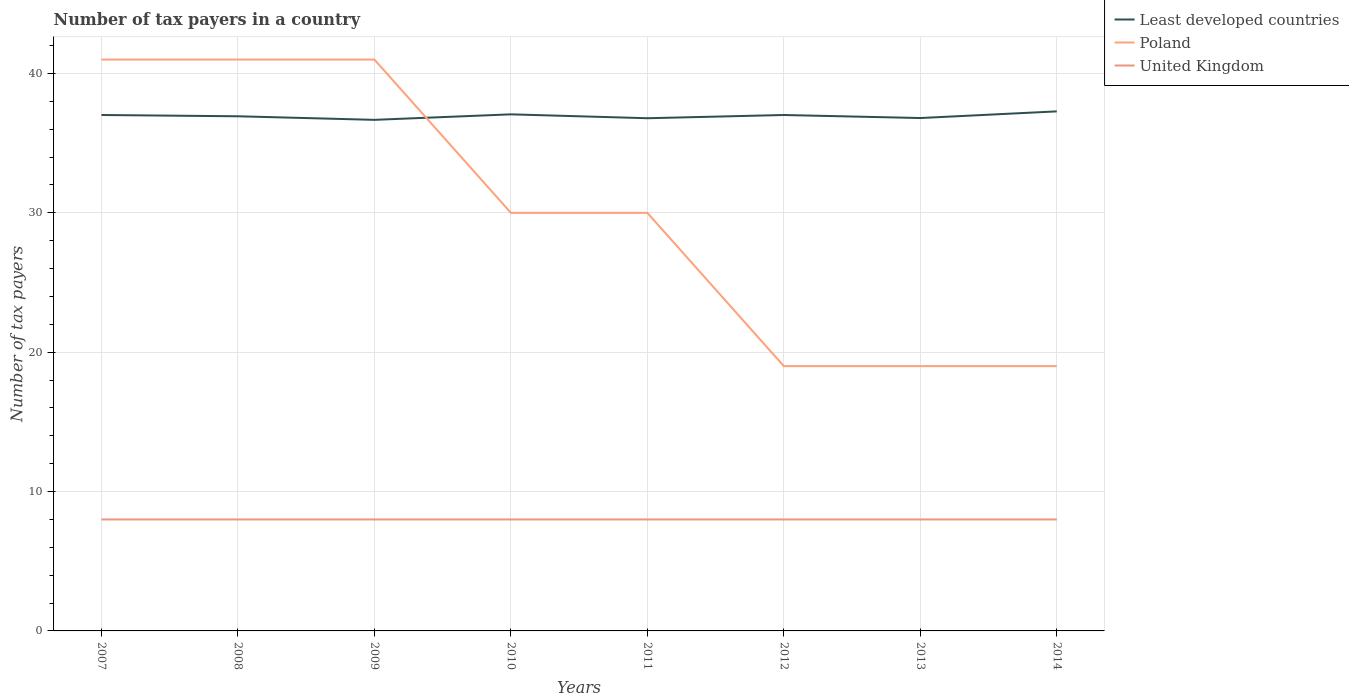How many different coloured lines are there?
Provide a short and direct response. 3. Across all years, what is the maximum number of tax payers in in United Kingdom?
Your answer should be compact. 8. Is the number of tax payers in in Poland strictly greater than the number of tax payers in in United Kingdom over the years?
Provide a succinct answer. No. How many years are there in the graph?
Provide a succinct answer. 8. What is the difference between two consecutive major ticks on the Y-axis?
Ensure brevity in your answer.  10. Does the graph contain any zero values?
Offer a very short reply. No. Where does the legend appear in the graph?
Your response must be concise. Top right. What is the title of the graph?
Give a very brief answer. Number of tax payers in a country. What is the label or title of the X-axis?
Keep it short and to the point. Years. What is the label or title of the Y-axis?
Give a very brief answer. Number of tax payers. What is the Number of tax payers in Least developed countries in 2007?
Keep it short and to the point. 37.02. What is the Number of tax payers in United Kingdom in 2007?
Keep it short and to the point. 8. What is the Number of tax payers in Least developed countries in 2008?
Ensure brevity in your answer.  36.93. What is the Number of tax payers of Poland in 2008?
Make the answer very short. 41. What is the Number of tax payers of Least developed countries in 2009?
Ensure brevity in your answer.  36.67. What is the Number of tax payers of United Kingdom in 2009?
Provide a succinct answer. 8. What is the Number of tax payers of Least developed countries in 2010?
Provide a succinct answer. 37.07. What is the Number of tax payers in Poland in 2010?
Offer a very short reply. 30. What is the Number of tax payers in Least developed countries in 2011?
Provide a short and direct response. 36.79. What is the Number of tax payers of Poland in 2011?
Ensure brevity in your answer.  30. What is the Number of tax payers in United Kingdom in 2011?
Provide a succinct answer. 8. What is the Number of tax payers in Least developed countries in 2012?
Your answer should be compact. 37.02. What is the Number of tax payers of United Kingdom in 2012?
Your answer should be very brief. 8. What is the Number of tax payers in Least developed countries in 2013?
Your answer should be compact. 36.8. What is the Number of tax payers in Least developed countries in 2014?
Offer a terse response. 37.28. What is the Number of tax payers in Poland in 2014?
Offer a terse response. 19. Across all years, what is the maximum Number of tax payers in Least developed countries?
Give a very brief answer. 37.28. Across all years, what is the maximum Number of tax payers of United Kingdom?
Provide a short and direct response. 8. Across all years, what is the minimum Number of tax payers in Least developed countries?
Your answer should be compact. 36.67. Across all years, what is the minimum Number of tax payers of Poland?
Offer a terse response. 19. What is the total Number of tax payers in Least developed countries in the graph?
Your answer should be compact. 295.6. What is the total Number of tax payers of Poland in the graph?
Give a very brief answer. 240. What is the total Number of tax payers in United Kingdom in the graph?
Offer a terse response. 64. What is the difference between the Number of tax payers in Least developed countries in 2007 and that in 2008?
Make the answer very short. 0.09. What is the difference between the Number of tax payers of Poland in 2007 and that in 2008?
Offer a terse response. 0. What is the difference between the Number of tax payers in United Kingdom in 2007 and that in 2008?
Make the answer very short. 0. What is the difference between the Number of tax payers in Least developed countries in 2007 and that in 2009?
Offer a terse response. 0.35. What is the difference between the Number of tax payers in Least developed countries in 2007 and that in 2010?
Offer a terse response. -0.05. What is the difference between the Number of tax payers of Poland in 2007 and that in 2010?
Provide a succinct answer. 11. What is the difference between the Number of tax payers of United Kingdom in 2007 and that in 2010?
Your answer should be very brief. 0. What is the difference between the Number of tax payers of Least developed countries in 2007 and that in 2011?
Your answer should be very brief. 0.23. What is the difference between the Number of tax payers in Poland in 2007 and that in 2011?
Offer a very short reply. 11. What is the difference between the Number of tax payers of Least developed countries in 2007 and that in 2012?
Your answer should be very brief. 0. What is the difference between the Number of tax payers of Least developed countries in 2007 and that in 2013?
Offer a terse response. 0.22. What is the difference between the Number of tax payers of Least developed countries in 2007 and that in 2014?
Provide a succinct answer. -0.26. What is the difference between the Number of tax payers of United Kingdom in 2007 and that in 2014?
Provide a short and direct response. 0. What is the difference between the Number of tax payers in Least developed countries in 2008 and that in 2009?
Give a very brief answer. 0.26. What is the difference between the Number of tax payers of Least developed countries in 2008 and that in 2010?
Give a very brief answer. -0.14. What is the difference between the Number of tax payers of Poland in 2008 and that in 2010?
Make the answer very short. 11. What is the difference between the Number of tax payers in Least developed countries in 2008 and that in 2011?
Offer a terse response. 0.14. What is the difference between the Number of tax payers in Poland in 2008 and that in 2011?
Provide a short and direct response. 11. What is the difference between the Number of tax payers of United Kingdom in 2008 and that in 2011?
Offer a terse response. 0. What is the difference between the Number of tax payers in Least developed countries in 2008 and that in 2012?
Keep it short and to the point. -0.09. What is the difference between the Number of tax payers in United Kingdom in 2008 and that in 2012?
Provide a succinct answer. 0. What is the difference between the Number of tax payers in Least developed countries in 2008 and that in 2013?
Keep it short and to the point. 0.13. What is the difference between the Number of tax payers of United Kingdom in 2008 and that in 2013?
Give a very brief answer. 0. What is the difference between the Number of tax payers in Least developed countries in 2008 and that in 2014?
Provide a succinct answer. -0.35. What is the difference between the Number of tax payers of United Kingdom in 2008 and that in 2014?
Provide a short and direct response. 0. What is the difference between the Number of tax payers of Least developed countries in 2009 and that in 2010?
Provide a short and direct response. -0.4. What is the difference between the Number of tax payers in Least developed countries in 2009 and that in 2011?
Provide a short and direct response. -0.12. What is the difference between the Number of tax payers in Poland in 2009 and that in 2011?
Your answer should be very brief. 11. What is the difference between the Number of tax payers of Least developed countries in 2009 and that in 2012?
Give a very brief answer. -0.35. What is the difference between the Number of tax payers in Poland in 2009 and that in 2012?
Make the answer very short. 22. What is the difference between the Number of tax payers of Least developed countries in 2009 and that in 2013?
Offer a terse response. -0.13. What is the difference between the Number of tax payers of United Kingdom in 2009 and that in 2013?
Offer a very short reply. 0. What is the difference between the Number of tax payers of Least developed countries in 2009 and that in 2014?
Your answer should be very brief. -0.61. What is the difference between the Number of tax payers in United Kingdom in 2009 and that in 2014?
Provide a succinct answer. 0. What is the difference between the Number of tax payers in Least developed countries in 2010 and that in 2011?
Provide a succinct answer. 0.28. What is the difference between the Number of tax payers of Poland in 2010 and that in 2011?
Offer a very short reply. 0. What is the difference between the Number of tax payers in United Kingdom in 2010 and that in 2011?
Ensure brevity in your answer.  0. What is the difference between the Number of tax payers of Least developed countries in 2010 and that in 2012?
Keep it short and to the point. 0.05. What is the difference between the Number of tax payers of United Kingdom in 2010 and that in 2012?
Provide a succinct answer. 0. What is the difference between the Number of tax payers in Least developed countries in 2010 and that in 2013?
Offer a very short reply. 0.27. What is the difference between the Number of tax payers of Least developed countries in 2010 and that in 2014?
Provide a short and direct response. -0.21. What is the difference between the Number of tax payers of Poland in 2010 and that in 2014?
Ensure brevity in your answer.  11. What is the difference between the Number of tax payers in United Kingdom in 2010 and that in 2014?
Provide a short and direct response. 0. What is the difference between the Number of tax payers of Least developed countries in 2011 and that in 2012?
Ensure brevity in your answer.  -0.23. What is the difference between the Number of tax payers of United Kingdom in 2011 and that in 2012?
Offer a terse response. 0. What is the difference between the Number of tax payers in Least developed countries in 2011 and that in 2013?
Offer a very short reply. -0.01. What is the difference between the Number of tax payers in Least developed countries in 2011 and that in 2014?
Provide a succinct answer. -0.49. What is the difference between the Number of tax payers of Least developed countries in 2012 and that in 2013?
Your response must be concise. 0.22. What is the difference between the Number of tax payers in United Kingdom in 2012 and that in 2013?
Give a very brief answer. 0. What is the difference between the Number of tax payers in Least developed countries in 2012 and that in 2014?
Keep it short and to the point. -0.26. What is the difference between the Number of tax payers in Least developed countries in 2013 and that in 2014?
Provide a short and direct response. -0.48. What is the difference between the Number of tax payers of Least developed countries in 2007 and the Number of tax payers of Poland in 2008?
Offer a terse response. -3.98. What is the difference between the Number of tax payers in Least developed countries in 2007 and the Number of tax payers in United Kingdom in 2008?
Provide a succinct answer. 29.02. What is the difference between the Number of tax payers in Poland in 2007 and the Number of tax payers in United Kingdom in 2008?
Give a very brief answer. 33. What is the difference between the Number of tax payers in Least developed countries in 2007 and the Number of tax payers in Poland in 2009?
Keep it short and to the point. -3.98. What is the difference between the Number of tax payers in Least developed countries in 2007 and the Number of tax payers in United Kingdom in 2009?
Make the answer very short. 29.02. What is the difference between the Number of tax payers in Least developed countries in 2007 and the Number of tax payers in Poland in 2010?
Make the answer very short. 7.02. What is the difference between the Number of tax payers in Least developed countries in 2007 and the Number of tax payers in United Kingdom in 2010?
Your response must be concise. 29.02. What is the difference between the Number of tax payers in Poland in 2007 and the Number of tax payers in United Kingdom in 2010?
Offer a very short reply. 33. What is the difference between the Number of tax payers of Least developed countries in 2007 and the Number of tax payers of Poland in 2011?
Offer a very short reply. 7.02. What is the difference between the Number of tax payers in Least developed countries in 2007 and the Number of tax payers in United Kingdom in 2011?
Ensure brevity in your answer.  29.02. What is the difference between the Number of tax payers in Poland in 2007 and the Number of tax payers in United Kingdom in 2011?
Provide a short and direct response. 33. What is the difference between the Number of tax payers of Least developed countries in 2007 and the Number of tax payers of Poland in 2012?
Your answer should be very brief. 18.02. What is the difference between the Number of tax payers in Least developed countries in 2007 and the Number of tax payers in United Kingdom in 2012?
Your answer should be compact. 29.02. What is the difference between the Number of tax payers in Poland in 2007 and the Number of tax payers in United Kingdom in 2012?
Ensure brevity in your answer.  33. What is the difference between the Number of tax payers in Least developed countries in 2007 and the Number of tax payers in Poland in 2013?
Keep it short and to the point. 18.02. What is the difference between the Number of tax payers in Least developed countries in 2007 and the Number of tax payers in United Kingdom in 2013?
Offer a terse response. 29.02. What is the difference between the Number of tax payers of Poland in 2007 and the Number of tax payers of United Kingdom in 2013?
Offer a very short reply. 33. What is the difference between the Number of tax payers of Least developed countries in 2007 and the Number of tax payers of Poland in 2014?
Offer a very short reply. 18.02. What is the difference between the Number of tax payers in Least developed countries in 2007 and the Number of tax payers in United Kingdom in 2014?
Keep it short and to the point. 29.02. What is the difference between the Number of tax payers of Least developed countries in 2008 and the Number of tax payers of Poland in 2009?
Make the answer very short. -4.07. What is the difference between the Number of tax payers in Least developed countries in 2008 and the Number of tax payers in United Kingdom in 2009?
Make the answer very short. 28.93. What is the difference between the Number of tax payers in Least developed countries in 2008 and the Number of tax payers in Poland in 2010?
Make the answer very short. 6.93. What is the difference between the Number of tax payers of Least developed countries in 2008 and the Number of tax payers of United Kingdom in 2010?
Make the answer very short. 28.93. What is the difference between the Number of tax payers in Poland in 2008 and the Number of tax payers in United Kingdom in 2010?
Keep it short and to the point. 33. What is the difference between the Number of tax payers in Least developed countries in 2008 and the Number of tax payers in Poland in 2011?
Provide a short and direct response. 6.93. What is the difference between the Number of tax payers in Least developed countries in 2008 and the Number of tax payers in United Kingdom in 2011?
Provide a short and direct response. 28.93. What is the difference between the Number of tax payers of Least developed countries in 2008 and the Number of tax payers of Poland in 2012?
Give a very brief answer. 17.93. What is the difference between the Number of tax payers of Least developed countries in 2008 and the Number of tax payers of United Kingdom in 2012?
Offer a terse response. 28.93. What is the difference between the Number of tax payers of Least developed countries in 2008 and the Number of tax payers of Poland in 2013?
Provide a succinct answer. 17.93. What is the difference between the Number of tax payers of Least developed countries in 2008 and the Number of tax payers of United Kingdom in 2013?
Offer a terse response. 28.93. What is the difference between the Number of tax payers of Least developed countries in 2008 and the Number of tax payers of Poland in 2014?
Make the answer very short. 17.93. What is the difference between the Number of tax payers of Least developed countries in 2008 and the Number of tax payers of United Kingdom in 2014?
Ensure brevity in your answer.  28.93. What is the difference between the Number of tax payers in Poland in 2008 and the Number of tax payers in United Kingdom in 2014?
Ensure brevity in your answer.  33. What is the difference between the Number of tax payers of Least developed countries in 2009 and the Number of tax payers of Poland in 2010?
Make the answer very short. 6.67. What is the difference between the Number of tax payers in Least developed countries in 2009 and the Number of tax payers in United Kingdom in 2010?
Your answer should be very brief. 28.67. What is the difference between the Number of tax payers of Least developed countries in 2009 and the Number of tax payers of Poland in 2011?
Your answer should be very brief. 6.67. What is the difference between the Number of tax payers in Least developed countries in 2009 and the Number of tax payers in United Kingdom in 2011?
Offer a terse response. 28.67. What is the difference between the Number of tax payers in Poland in 2009 and the Number of tax payers in United Kingdom in 2011?
Offer a very short reply. 33. What is the difference between the Number of tax payers in Least developed countries in 2009 and the Number of tax payers in Poland in 2012?
Keep it short and to the point. 17.67. What is the difference between the Number of tax payers in Least developed countries in 2009 and the Number of tax payers in United Kingdom in 2012?
Offer a terse response. 28.67. What is the difference between the Number of tax payers in Least developed countries in 2009 and the Number of tax payers in Poland in 2013?
Offer a very short reply. 17.67. What is the difference between the Number of tax payers in Least developed countries in 2009 and the Number of tax payers in United Kingdom in 2013?
Your answer should be compact. 28.67. What is the difference between the Number of tax payers in Least developed countries in 2009 and the Number of tax payers in Poland in 2014?
Offer a terse response. 17.67. What is the difference between the Number of tax payers of Least developed countries in 2009 and the Number of tax payers of United Kingdom in 2014?
Keep it short and to the point. 28.67. What is the difference between the Number of tax payers of Least developed countries in 2010 and the Number of tax payers of Poland in 2011?
Your answer should be very brief. 7.07. What is the difference between the Number of tax payers in Least developed countries in 2010 and the Number of tax payers in United Kingdom in 2011?
Make the answer very short. 29.07. What is the difference between the Number of tax payers of Poland in 2010 and the Number of tax payers of United Kingdom in 2011?
Give a very brief answer. 22. What is the difference between the Number of tax payers in Least developed countries in 2010 and the Number of tax payers in Poland in 2012?
Your response must be concise. 18.07. What is the difference between the Number of tax payers in Least developed countries in 2010 and the Number of tax payers in United Kingdom in 2012?
Provide a succinct answer. 29.07. What is the difference between the Number of tax payers of Poland in 2010 and the Number of tax payers of United Kingdom in 2012?
Offer a very short reply. 22. What is the difference between the Number of tax payers in Least developed countries in 2010 and the Number of tax payers in Poland in 2013?
Offer a very short reply. 18.07. What is the difference between the Number of tax payers in Least developed countries in 2010 and the Number of tax payers in United Kingdom in 2013?
Provide a short and direct response. 29.07. What is the difference between the Number of tax payers in Least developed countries in 2010 and the Number of tax payers in Poland in 2014?
Make the answer very short. 18.07. What is the difference between the Number of tax payers of Least developed countries in 2010 and the Number of tax payers of United Kingdom in 2014?
Make the answer very short. 29.07. What is the difference between the Number of tax payers in Poland in 2010 and the Number of tax payers in United Kingdom in 2014?
Provide a succinct answer. 22. What is the difference between the Number of tax payers in Least developed countries in 2011 and the Number of tax payers in Poland in 2012?
Your response must be concise. 17.79. What is the difference between the Number of tax payers in Least developed countries in 2011 and the Number of tax payers in United Kingdom in 2012?
Offer a terse response. 28.79. What is the difference between the Number of tax payers in Least developed countries in 2011 and the Number of tax payers in Poland in 2013?
Make the answer very short. 17.79. What is the difference between the Number of tax payers in Least developed countries in 2011 and the Number of tax payers in United Kingdom in 2013?
Offer a very short reply. 28.79. What is the difference between the Number of tax payers in Least developed countries in 2011 and the Number of tax payers in Poland in 2014?
Keep it short and to the point. 17.79. What is the difference between the Number of tax payers in Least developed countries in 2011 and the Number of tax payers in United Kingdom in 2014?
Offer a terse response. 28.79. What is the difference between the Number of tax payers in Poland in 2011 and the Number of tax payers in United Kingdom in 2014?
Keep it short and to the point. 22. What is the difference between the Number of tax payers of Least developed countries in 2012 and the Number of tax payers of Poland in 2013?
Your response must be concise. 18.02. What is the difference between the Number of tax payers in Least developed countries in 2012 and the Number of tax payers in United Kingdom in 2013?
Make the answer very short. 29.02. What is the difference between the Number of tax payers of Least developed countries in 2012 and the Number of tax payers of Poland in 2014?
Provide a succinct answer. 18.02. What is the difference between the Number of tax payers of Least developed countries in 2012 and the Number of tax payers of United Kingdom in 2014?
Give a very brief answer. 29.02. What is the difference between the Number of tax payers in Poland in 2012 and the Number of tax payers in United Kingdom in 2014?
Provide a short and direct response. 11. What is the difference between the Number of tax payers of Least developed countries in 2013 and the Number of tax payers of Poland in 2014?
Give a very brief answer. 17.8. What is the difference between the Number of tax payers of Least developed countries in 2013 and the Number of tax payers of United Kingdom in 2014?
Provide a succinct answer. 28.8. What is the average Number of tax payers in Least developed countries per year?
Offer a very short reply. 36.95. In the year 2007, what is the difference between the Number of tax payers in Least developed countries and Number of tax payers in Poland?
Give a very brief answer. -3.98. In the year 2007, what is the difference between the Number of tax payers in Least developed countries and Number of tax payers in United Kingdom?
Your answer should be very brief. 29.02. In the year 2008, what is the difference between the Number of tax payers in Least developed countries and Number of tax payers in Poland?
Offer a very short reply. -4.07. In the year 2008, what is the difference between the Number of tax payers of Least developed countries and Number of tax payers of United Kingdom?
Your response must be concise. 28.93. In the year 2008, what is the difference between the Number of tax payers in Poland and Number of tax payers in United Kingdom?
Provide a short and direct response. 33. In the year 2009, what is the difference between the Number of tax payers of Least developed countries and Number of tax payers of Poland?
Keep it short and to the point. -4.33. In the year 2009, what is the difference between the Number of tax payers in Least developed countries and Number of tax payers in United Kingdom?
Offer a terse response. 28.67. In the year 2009, what is the difference between the Number of tax payers in Poland and Number of tax payers in United Kingdom?
Provide a succinct answer. 33. In the year 2010, what is the difference between the Number of tax payers in Least developed countries and Number of tax payers in Poland?
Offer a terse response. 7.07. In the year 2010, what is the difference between the Number of tax payers in Least developed countries and Number of tax payers in United Kingdom?
Your answer should be compact. 29.07. In the year 2011, what is the difference between the Number of tax payers in Least developed countries and Number of tax payers in Poland?
Provide a succinct answer. 6.79. In the year 2011, what is the difference between the Number of tax payers in Least developed countries and Number of tax payers in United Kingdom?
Offer a terse response. 28.79. In the year 2011, what is the difference between the Number of tax payers of Poland and Number of tax payers of United Kingdom?
Your answer should be compact. 22. In the year 2012, what is the difference between the Number of tax payers in Least developed countries and Number of tax payers in Poland?
Offer a very short reply. 18.02. In the year 2012, what is the difference between the Number of tax payers of Least developed countries and Number of tax payers of United Kingdom?
Your response must be concise. 29.02. In the year 2012, what is the difference between the Number of tax payers in Poland and Number of tax payers in United Kingdom?
Make the answer very short. 11. In the year 2013, what is the difference between the Number of tax payers of Least developed countries and Number of tax payers of Poland?
Provide a succinct answer. 17.8. In the year 2013, what is the difference between the Number of tax payers in Least developed countries and Number of tax payers in United Kingdom?
Ensure brevity in your answer.  28.8. In the year 2013, what is the difference between the Number of tax payers of Poland and Number of tax payers of United Kingdom?
Your answer should be very brief. 11. In the year 2014, what is the difference between the Number of tax payers of Least developed countries and Number of tax payers of Poland?
Offer a terse response. 18.28. In the year 2014, what is the difference between the Number of tax payers in Least developed countries and Number of tax payers in United Kingdom?
Make the answer very short. 29.28. What is the ratio of the Number of tax payers in Poland in 2007 to that in 2008?
Keep it short and to the point. 1. What is the ratio of the Number of tax payers of United Kingdom in 2007 to that in 2008?
Offer a very short reply. 1. What is the ratio of the Number of tax payers in Least developed countries in 2007 to that in 2009?
Make the answer very short. 1.01. What is the ratio of the Number of tax payers in Poland in 2007 to that in 2009?
Offer a very short reply. 1. What is the ratio of the Number of tax payers in Poland in 2007 to that in 2010?
Keep it short and to the point. 1.37. What is the ratio of the Number of tax payers of United Kingdom in 2007 to that in 2010?
Provide a succinct answer. 1. What is the ratio of the Number of tax payers in Poland in 2007 to that in 2011?
Keep it short and to the point. 1.37. What is the ratio of the Number of tax payers of Least developed countries in 2007 to that in 2012?
Ensure brevity in your answer.  1. What is the ratio of the Number of tax payers in Poland in 2007 to that in 2012?
Your answer should be compact. 2.16. What is the ratio of the Number of tax payers in United Kingdom in 2007 to that in 2012?
Offer a very short reply. 1. What is the ratio of the Number of tax payers in Least developed countries in 2007 to that in 2013?
Your answer should be compact. 1.01. What is the ratio of the Number of tax payers of Poland in 2007 to that in 2013?
Your answer should be very brief. 2.16. What is the ratio of the Number of tax payers in United Kingdom in 2007 to that in 2013?
Offer a very short reply. 1. What is the ratio of the Number of tax payers in Least developed countries in 2007 to that in 2014?
Provide a succinct answer. 0.99. What is the ratio of the Number of tax payers in Poland in 2007 to that in 2014?
Offer a terse response. 2.16. What is the ratio of the Number of tax payers in United Kingdom in 2007 to that in 2014?
Your answer should be very brief. 1. What is the ratio of the Number of tax payers in Poland in 2008 to that in 2009?
Provide a succinct answer. 1. What is the ratio of the Number of tax payers of Poland in 2008 to that in 2010?
Ensure brevity in your answer.  1.37. What is the ratio of the Number of tax payers in Least developed countries in 2008 to that in 2011?
Your response must be concise. 1. What is the ratio of the Number of tax payers of Poland in 2008 to that in 2011?
Make the answer very short. 1.37. What is the ratio of the Number of tax payers of Poland in 2008 to that in 2012?
Your response must be concise. 2.16. What is the ratio of the Number of tax payers of United Kingdom in 2008 to that in 2012?
Your answer should be compact. 1. What is the ratio of the Number of tax payers in Poland in 2008 to that in 2013?
Offer a very short reply. 2.16. What is the ratio of the Number of tax payers of Poland in 2008 to that in 2014?
Ensure brevity in your answer.  2.16. What is the ratio of the Number of tax payers in Least developed countries in 2009 to that in 2010?
Provide a short and direct response. 0.99. What is the ratio of the Number of tax payers in Poland in 2009 to that in 2010?
Make the answer very short. 1.37. What is the ratio of the Number of tax payers in Poland in 2009 to that in 2011?
Provide a short and direct response. 1.37. What is the ratio of the Number of tax payers in United Kingdom in 2009 to that in 2011?
Offer a terse response. 1. What is the ratio of the Number of tax payers of Least developed countries in 2009 to that in 2012?
Your answer should be very brief. 0.99. What is the ratio of the Number of tax payers of Poland in 2009 to that in 2012?
Provide a short and direct response. 2.16. What is the ratio of the Number of tax payers in Poland in 2009 to that in 2013?
Provide a succinct answer. 2.16. What is the ratio of the Number of tax payers of United Kingdom in 2009 to that in 2013?
Provide a succinct answer. 1. What is the ratio of the Number of tax payers in Least developed countries in 2009 to that in 2014?
Provide a succinct answer. 0.98. What is the ratio of the Number of tax payers of Poland in 2009 to that in 2014?
Provide a succinct answer. 2.16. What is the ratio of the Number of tax payers of United Kingdom in 2009 to that in 2014?
Offer a terse response. 1. What is the ratio of the Number of tax payers in Least developed countries in 2010 to that in 2011?
Offer a terse response. 1.01. What is the ratio of the Number of tax payers in Least developed countries in 2010 to that in 2012?
Give a very brief answer. 1. What is the ratio of the Number of tax payers in Poland in 2010 to that in 2012?
Offer a terse response. 1.58. What is the ratio of the Number of tax payers in Poland in 2010 to that in 2013?
Offer a very short reply. 1.58. What is the ratio of the Number of tax payers in United Kingdom in 2010 to that in 2013?
Make the answer very short. 1. What is the ratio of the Number of tax payers of Least developed countries in 2010 to that in 2014?
Your answer should be very brief. 0.99. What is the ratio of the Number of tax payers of Poland in 2010 to that in 2014?
Provide a short and direct response. 1.58. What is the ratio of the Number of tax payers in Least developed countries in 2011 to that in 2012?
Your answer should be very brief. 0.99. What is the ratio of the Number of tax payers in Poland in 2011 to that in 2012?
Provide a short and direct response. 1.58. What is the ratio of the Number of tax payers in United Kingdom in 2011 to that in 2012?
Keep it short and to the point. 1. What is the ratio of the Number of tax payers of Poland in 2011 to that in 2013?
Ensure brevity in your answer.  1.58. What is the ratio of the Number of tax payers in Poland in 2011 to that in 2014?
Provide a succinct answer. 1.58. What is the ratio of the Number of tax payers of United Kingdom in 2011 to that in 2014?
Your answer should be very brief. 1. What is the ratio of the Number of tax payers in Least developed countries in 2012 to that in 2013?
Provide a short and direct response. 1.01. What is the ratio of the Number of tax payers in Poland in 2012 to that in 2013?
Your answer should be very brief. 1. What is the ratio of the Number of tax payers in United Kingdom in 2012 to that in 2013?
Make the answer very short. 1. What is the ratio of the Number of tax payers in Poland in 2012 to that in 2014?
Your answer should be very brief. 1. What is the ratio of the Number of tax payers in United Kingdom in 2012 to that in 2014?
Your response must be concise. 1. What is the ratio of the Number of tax payers in Least developed countries in 2013 to that in 2014?
Make the answer very short. 0.99. What is the ratio of the Number of tax payers in United Kingdom in 2013 to that in 2014?
Offer a terse response. 1. What is the difference between the highest and the second highest Number of tax payers in Least developed countries?
Your response must be concise. 0.21. What is the difference between the highest and the second highest Number of tax payers in Poland?
Offer a terse response. 0. What is the difference between the highest and the lowest Number of tax payers in Least developed countries?
Keep it short and to the point. 0.61. 